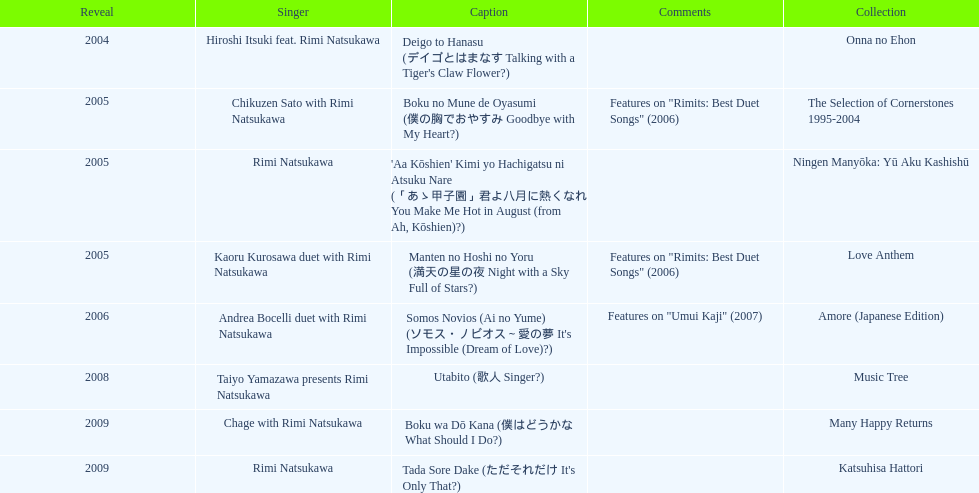What is the last title released? 2009. 